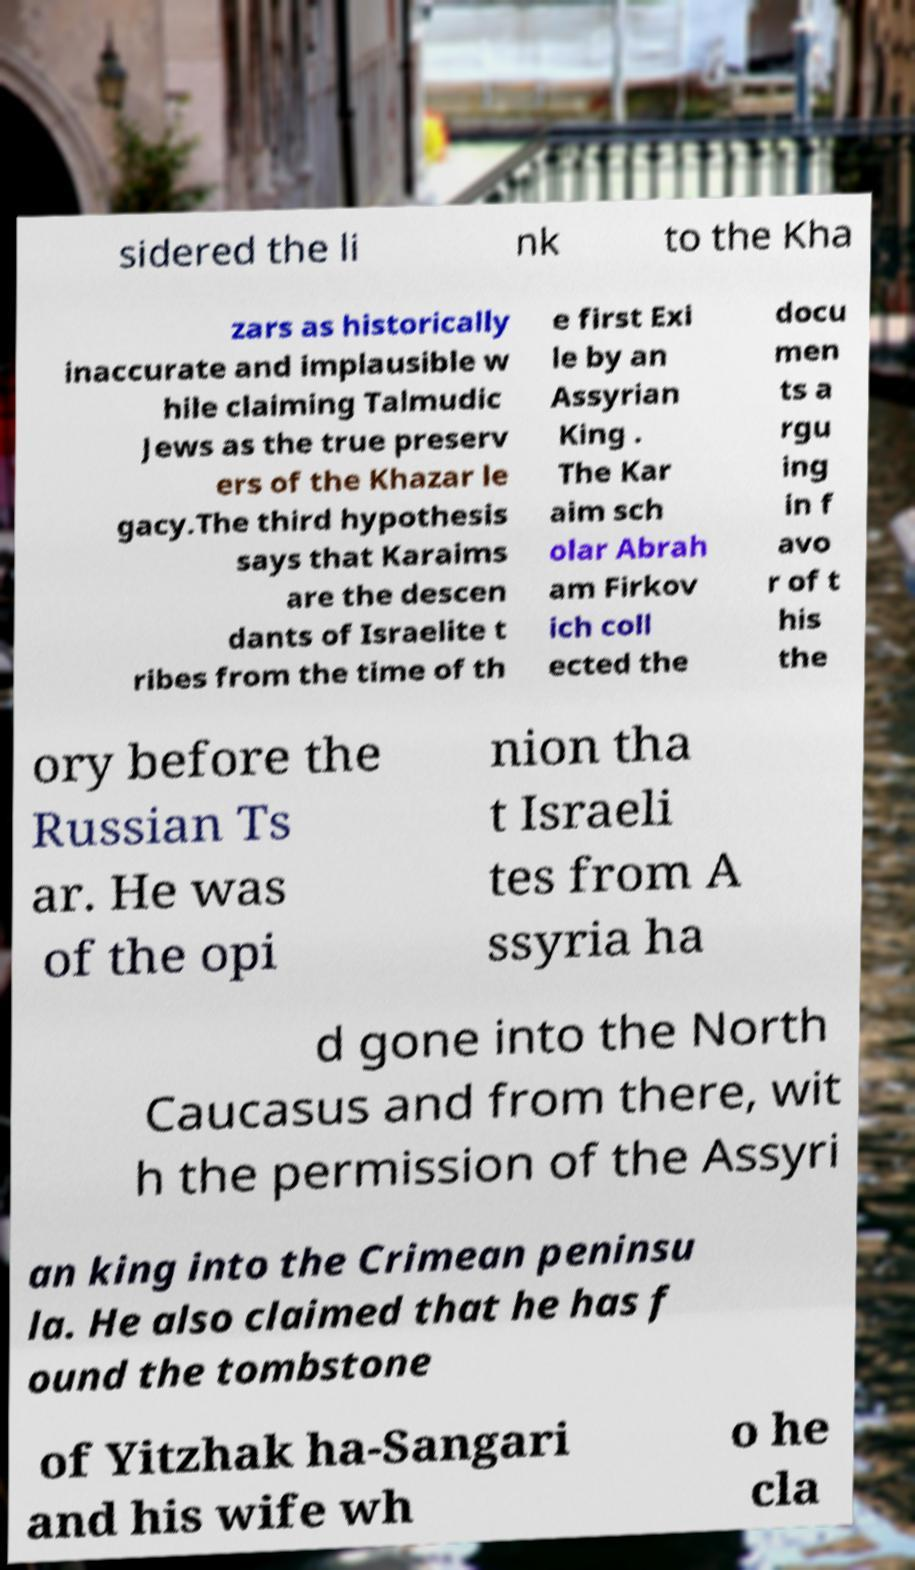There's text embedded in this image that I need extracted. Can you transcribe it verbatim? sidered the li nk to the Kha zars as historically inaccurate and implausible w hile claiming Talmudic Jews as the true preserv ers of the Khazar le gacy.The third hypothesis says that Karaims are the descen dants of Israelite t ribes from the time of th e first Exi le by an Assyrian King . The Kar aim sch olar Abrah am Firkov ich coll ected the docu men ts a rgu ing in f avo r of t his the ory before the Russian Ts ar. He was of the opi nion tha t Israeli tes from A ssyria ha d gone into the North Caucasus and from there, wit h the permission of the Assyri an king into the Crimean peninsu la. He also claimed that he has f ound the tombstone of Yitzhak ha-Sangari and his wife wh o he cla 